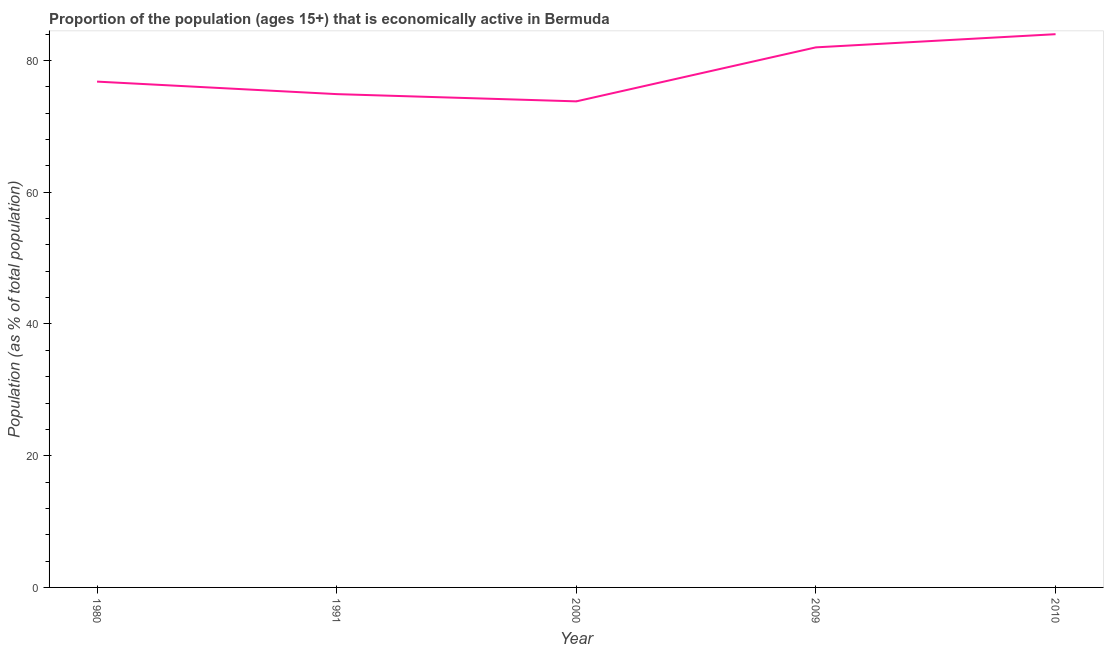What is the percentage of economically active population in 2000?
Provide a short and direct response. 73.8. Across all years, what is the minimum percentage of economically active population?
Your response must be concise. 73.8. In which year was the percentage of economically active population minimum?
Provide a short and direct response. 2000. What is the sum of the percentage of economically active population?
Your answer should be very brief. 391.5. What is the difference between the percentage of economically active population in 2000 and 2009?
Your answer should be compact. -8.2. What is the average percentage of economically active population per year?
Ensure brevity in your answer.  78.3. What is the median percentage of economically active population?
Your answer should be compact. 76.8. Do a majority of the years between 2009 and 1980 (inclusive) have percentage of economically active population greater than 4 %?
Your answer should be very brief. Yes. What is the ratio of the percentage of economically active population in 2009 to that in 2010?
Make the answer very short. 0.98. What is the difference between the highest and the second highest percentage of economically active population?
Give a very brief answer. 2. Is the sum of the percentage of economically active population in 1980 and 2000 greater than the maximum percentage of economically active population across all years?
Provide a succinct answer. Yes. What is the difference between the highest and the lowest percentage of economically active population?
Provide a succinct answer. 10.2. Does the percentage of economically active population monotonically increase over the years?
Provide a succinct answer. No. How many lines are there?
Your answer should be compact. 1. Does the graph contain grids?
Provide a short and direct response. No. What is the title of the graph?
Your answer should be compact. Proportion of the population (ages 15+) that is economically active in Bermuda. What is the label or title of the X-axis?
Provide a succinct answer. Year. What is the label or title of the Y-axis?
Offer a terse response. Population (as % of total population). What is the Population (as % of total population) of 1980?
Offer a very short reply. 76.8. What is the Population (as % of total population) in 1991?
Provide a short and direct response. 74.9. What is the Population (as % of total population) in 2000?
Your response must be concise. 73.8. What is the difference between the Population (as % of total population) in 1991 and 2000?
Offer a very short reply. 1.1. What is the difference between the Population (as % of total population) in 1991 and 2009?
Make the answer very short. -7.1. What is the difference between the Population (as % of total population) in 1991 and 2010?
Offer a very short reply. -9.1. What is the difference between the Population (as % of total population) in 2000 and 2009?
Keep it short and to the point. -8.2. What is the ratio of the Population (as % of total population) in 1980 to that in 2000?
Give a very brief answer. 1.04. What is the ratio of the Population (as % of total population) in 1980 to that in 2009?
Make the answer very short. 0.94. What is the ratio of the Population (as % of total population) in 1980 to that in 2010?
Your response must be concise. 0.91. What is the ratio of the Population (as % of total population) in 1991 to that in 2010?
Give a very brief answer. 0.89. What is the ratio of the Population (as % of total population) in 2000 to that in 2009?
Give a very brief answer. 0.9. What is the ratio of the Population (as % of total population) in 2000 to that in 2010?
Keep it short and to the point. 0.88. 